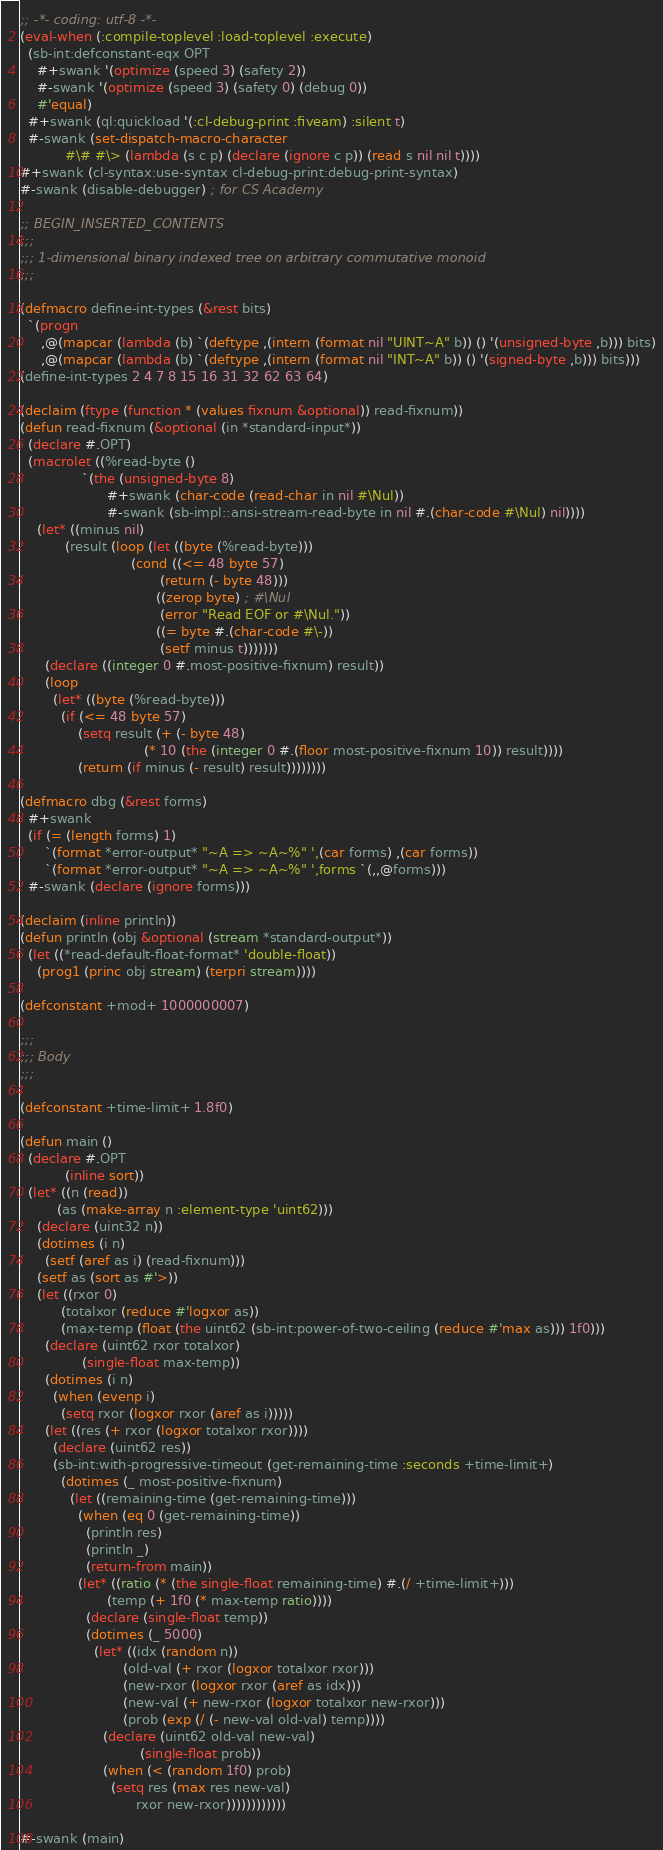<code> <loc_0><loc_0><loc_500><loc_500><_Lisp_>;; -*- coding: utf-8 -*-
(eval-when (:compile-toplevel :load-toplevel :execute)
  (sb-int:defconstant-eqx OPT
    #+swank '(optimize (speed 3) (safety 2))
    #-swank '(optimize (speed 3) (safety 0) (debug 0))
    #'equal)
  #+swank (ql:quickload '(:cl-debug-print :fiveam) :silent t)
  #-swank (set-dispatch-macro-character
           #\# #\> (lambda (s c p) (declare (ignore c p)) (read s nil nil t))))
#+swank (cl-syntax:use-syntax cl-debug-print:debug-print-syntax)
#-swank (disable-debugger) ; for CS Academy

;; BEGIN_INSERTED_CONTENTS
;;;
;;; 1-dimensional binary indexed tree on arbitrary commutative monoid
;;;

(defmacro define-int-types (&rest bits)
  `(progn
     ,@(mapcar (lambda (b) `(deftype ,(intern (format nil "UINT~A" b)) () '(unsigned-byte ,b))) bits)
     ,@(mapcar (lambda (b) `(deftype ,(intern (format nil "INT~A" b)) () '(signed-byte ,b))) bits)))
(define-int-types 2 4 7 8 15 16 31 32 62 63 64)

(declaim (ftype (function * (values fixnum &optional)) read-fixnum))
(defun read-fixnum (&optional (in *standard-input*))
  (declare #.OPT)
  (macrolet ((%read-byte ()
               `(the (unsigned-byte 8)
                     #+swank (char-code (read-char in nil #\Nul))
                     #-swank (sb-impl::ansi-stream-read-byte in nil #.(char-code #\Nul) nil))))
    (let* ((minus nil)
           (result (loop (let ((byte (%read-byte)))
                           (cond ((<= 48 byte 57)
                                  (return (- byte 48)))
                                 ((zerop byte) ; #\Nul
                                  (error "Read EOF or #\Nul."))
                                 ((= byte #.(char-code #\-))
                                  (setf minus t)))))))
      (declare ((integer 0 #.most-positive-fixnum) result))
      (loop
        (let* ((byte (%read-byte)))
          (if (<= 48 byte 57)
              (setq result (+ (- byte 48)
                              (* 10 (the (integer 0 #.(floor most-positive-fixnum 10)) result))))
              (return (if minus (- result) result))))))))

(defmacro dbg (&rest forms)
  #+swank
  (if (= (length forms) 1)
      `(format *error-output* "~A => ~A~%" ',(car forms) ,(car forms))
      `(format *error-output* "~A => ~A~%" ',forms `(,,@forms)))
  #-swank (declare (ignore forms)))

(declaim (inline println))
(defun println (obj &optional (stream *standard-output*))
  (let ((*read-default-float-format* 'double-float))
    (prog1 (princ obj stream) (terpri stream))))

(defconstant +mod+ 1000000007)

;;;
;;; Body
;;;

(defconstant +time-limit+ 1.8f0)

(defun main ()
  (declare #.OPT
           (inline sort))
  (let* ((n (read))
         (as (make-array n :element-type 'uint62)))
    (declare (uint32 n))
    (dotimes (i n)
      (setf (aref as i) (read-fixnum)))
    (setf as (sort as #'>))
    (let ((rxor 0)
          (totalxor (reduce #'logxor as))
          (max-temp (float (the uint62 (sb-int:power-of-two-ceiling (reduce #'max as))) 1f0)))
      (declare (uint62 rxor totalxor)
               (single-float max-temp))
      (dotimes (i n)
        (when (evenp i)
          (setq rxor (logxor rxor (aref as i)))))
      (let ((res (+ rxor (logxor totalxor rxor))))
        (declare (uint62 res))
        (sb-int:with-progressive-timeout (get-remaining-time :seconds +time-limit+)
          (dotimes (_ most-positive-fixnum)
            (let ((remaining-time (get-remaining-time)))
              (when (eq 0 (get-remaining-time))
                (println res)
                (println _)
                (return-from main))
              (let* ((ratio (* (the single-float remaining-time) #.(/ +time-limit+)))
                     (temp (+ 1f0 (* max-temp ratio))))
                (declare (single-float temp))
                (dotimes (_ 5000)
                  (let* ((idx (random n))
                         (old-val (+ rxor (logxor totalxor rxor)))
                         (new-rxor (logxor rxor (aref as idx)))
                         (new-val (+ new-rxor (logxor totalxor new-rxor)))
                         (prob (exp (/ (- new-val old-val) temp))))
                    (declare (uint62 old-val new-val)
                             (single-float prob))
                    (when (< (random 1f0) prob)
                      (setq res (max res new-val)
                            rxor new-rxor))))))))))))

#-swank (main)
</code> 